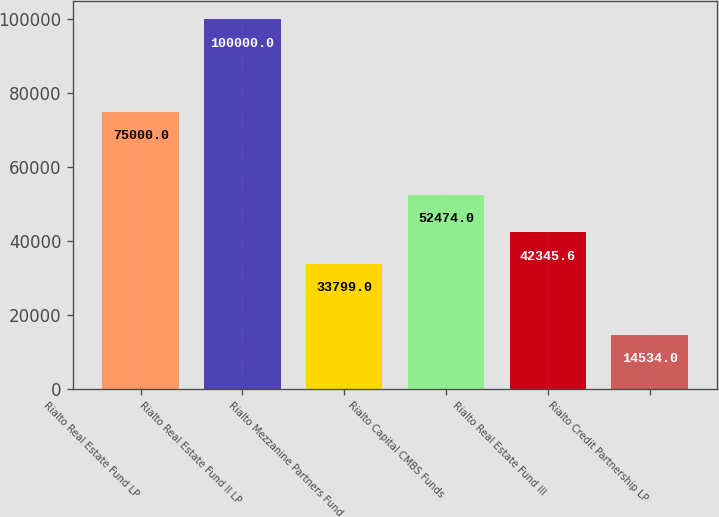<chart> <loc_0><loc_0><loc_500><loc_500><bar_chart><fcel>Rialto Real Estate Fund LP<fcel>Rialto Real Estate Fund II LP<fcel>Rialto Mezzanine Partners Fund<fcel>Rialto Capital CMBS Funds<fcel>Rialto Real Estate Fund III<fcel>Rialto Credit Partnership LP<nl><fcel>75000<fcel>100000<fcel>33799<fcel>52474<fcel>42345.6<fcel>14534<nl></chart> 